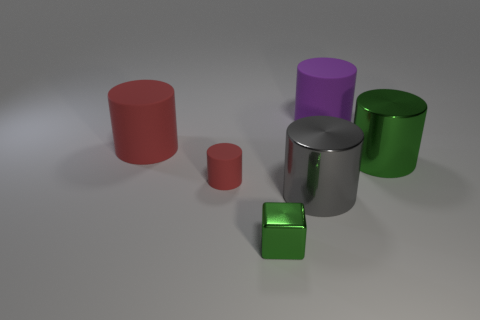Subtract all gray cylinders. How many cylinders are left? 4 Subtract all purple cylinders. How many cylinders are left? 4 Subtract all green cylinders. Subtract all green balls. How many cylinders are left? 4 Add 1 big metal cylinders. How many objects exist? 7 Subtract all blocks. How many objects are left? 5 Add 6 large cylinders. How many large cylinders exist? 10 Subtract 0 gray cubes. How many objects are left? 6 Subtract all gray rubber blocks. Subtract all big purple matte cylinders. How many objects are left? 5 Add 6 small rubber cylinders. How many small rubber cylinders are left? 7 